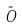Convert formula to latex. <formula><loc_0><loc_0><loc_500><loc_500>\tilde { O }</formula> 